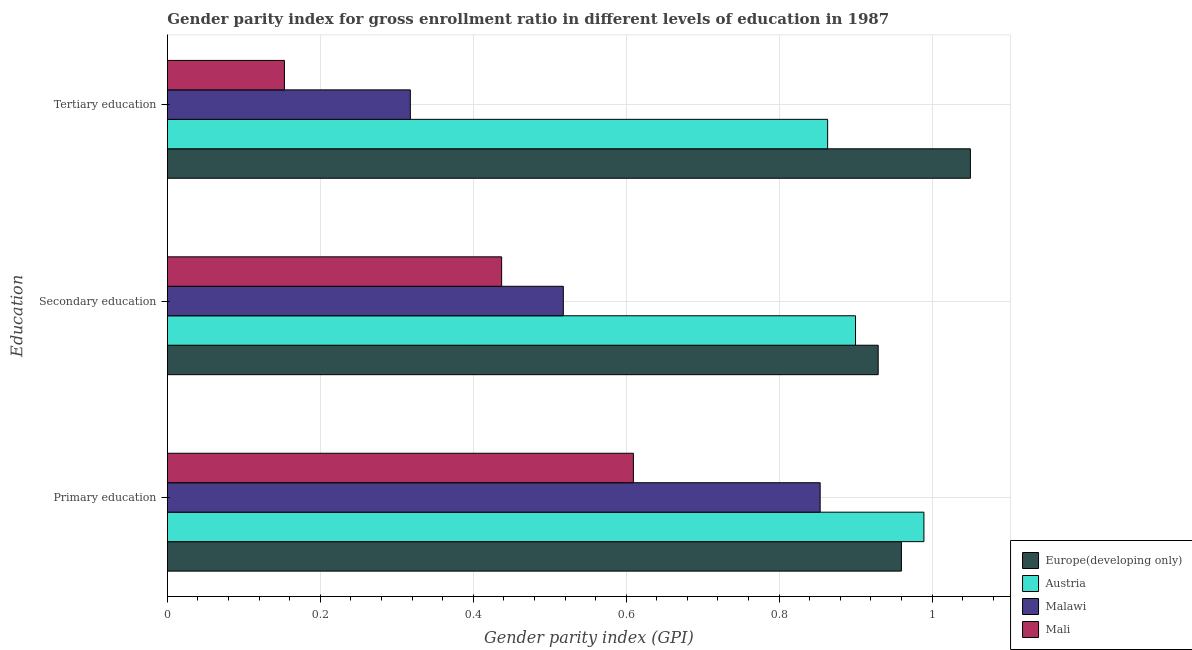How many different coloured bars are there?
Your answer should be compact. 4. How many bars are there on the 1st tick from the top?
Keep it short and to the point. 4. How many bars are there on the 3rd tick from the bottom?
Your response must be concise. 4. What is the label of the 3rd group of bars from the top?
Keep it short and to the point. Primary education. What is the gender parity index in secondary education in Malawi?
Keep it short and to the point. 0.52. Across all countries, what is the maximum gender parity index in secondary education?
Provide a succinct answer. 0.93. Across all countries, what is the minimum gender parity index in secondary education?
Provide a short and direct response. 0.44. In which country was the gender parity index in secondary education maximum?
Offer a terse response. Europe(developing only). In which country was the gender parity index in secondary education minimum?
Offer a very short reply. Mali. What is the total gender parity index in secondary education in the graph?
Offer a very short reply. 2.78. What is the difference between the gender parity index in secondary education in Malawi and that in Austria?
Offer a very short reply. -0.38. What is the difference between the gender parity index in secondary education in Europe(developing only) and the gender parity index in tertiary education in Malawi?
Ensure brevity in your answer.  0.61. What is the average gender parity index in primary education per country?
Offer a very short reply. 0.85. What is the difference between the gender parity index in primary education and gender parity index in secondary education in Malawi?
Provide a succinct answer. 0.34. In how many countries, is the gender parity index in primary education greater than 0.92 ?
Ensure brevity in your answer.  2. What is the ratio of the gender parity index in primary education in Austria to that in Europe(developing only)?
Offer a terse response. 1.03. Is the gender parity index in secondary education in Austria less than that in Europe(developing only)?
Give a very brief answer. Yes. What is the difference between the highest and the second highest gender parity index in secondary education?
Your response must be concise. 0.03. What is the difference between the highest and the lowest gender parity index in tertiary education?
Provide a short and direct response. 0.9. In how many countries, is the gender parity index in tertiary education greater than the average gender parity index in tertiary education taken over all countries?
Ensure brevity in your answer.  2. What does the 4th bar from the top in Primary education represents?
Give a very brief answer. Europe(developing only). What does the 4th bar from the bottom in Tertiary education represents?
Provide a short and direct response. Mali. How many bars are there?
Offer a terse response. 12. How many countries are there in the graph?
Give a very brief answer. 4. Does the graph contain any zero values?
Keep it short and to the point. No. Does the graph contain grids?
Offer a terse response. Yes. Where does the legend appear in the graph?
Give a very brief answer. Bottom right. How many legend labels are there?
Make the answer very short. 4. What is the title of the graph?
Your response must be concise. Gender parity index for gross enrollment ratio in different levels of education in 1987. What is the label or title of the X-axis?
Your response must be concise. Gender parity index (GPI). What is the label or title of the Y-axis?
Keep it short and to the point. Education. What is the Gender parity index (GPI) of Europe(developing only) in Primary education?
Your response must be concise. 0.96. What is the Gender parity index (GPI) of Austria in Primary education?
Give a very brief answer. 0.99. What is the Gender parity index (GPI) of Malawi in Primary education?
Make the answer very short. 0.85. What is the Gender parity index (GPI) in Mali in Primary education?
Your answer should be very brief. 0.61. What is the Gender parity index (GPI) of Europe(developing only) in Secondary education?
Make the answer very short. 0.93. What is the Gender parity index (GPI) in Austria in Secondary education?
Give a very brief answer. 0.9. What is the Gender parity index (GPI) in Malawi in Secondary education?
Offer a very short reply. 0.52. What is the Gender parity index (GPI) of Mali in Secondary education?
Provide a succinct answer. 0.44. What is the Gender parity index (GPI) of Europe(developing only) in Tertiary education?
Make the answer very short. 1.05. What is the Gender parity index (GPI) in Austria in Tertiary education?
Your answer should be compact. 0.86. What is the Gender parity index (GPI) in Malawi in Tertiary education?
Your answer should be very brief. 0.32. What is the Gender parity index (GPI) in Mali in Tertiary education?
Keep it short and to the point. 0.15. Across all Education, what is the maximum Gender parity index (GPI) of Europe(developing only)?
Give a very brief answer. 1.05. Across all Education, what is the maximum Gender parity index (GPI) of Austria?
Provide a short and direct response. 0.99. Across all Education, what is the maximum Gender parity index (GPI) in Malawi?
Your response must be concise. 0.85. Across all Education, what is the maximum Gender parity index (GPI) of Mali?
Give a very brief answer. 0.61. Across all Education, what is the minimum Gender parity index (GPI) in Europe(developing only)?
Provide a short and direct response. 0.93. Across all Education, what is the minimum Gender parity index (GPI) of Austria?
Your answer should be compact. 0.86. Across all Education, what is the minimum Gender parity index (GPI) in Malawi?
Offer a terse response. 0.32. Across all Education, what is the minimum Gender parity index (GPI) in Mali?
Your response must be concise. 0.15. What is the total Gender parity index (GPI) in Europe(developing only) in the graph?
Keep it short and to the point. 2.94. What is the total Gender parity index (GPI) of Austria in the graph?
Provide a succinct answer. 2.75. What is the total Gender parity index (GPI) in Malawi in the graph?
Your answer should be very brief. 1.69. What is the total Gender parity index (GPI) in Mali in the graph?
Offer a terse response. 1.2. What is the difference between the Gender parity index (GPI) of Europe(developing only) in Primary education and that in Secondary education?
Ensure brevity in your answer.  0.03. What is the difference between the Gender parity index (GPI) in Austria in Primary education and that in Secondary education?
Offer a very short reply. 0.09. What is the difference between the Gender parity index (GPI) in Malawi in Primary education and that in Secondary education?
Offer a very short reply. 0.34. What is the difference between the Gender parity index (GPI) in Mali in Primary education and that in Secondary education?
Give a very brief answer. 0.17. What is the difference between the Gender parity index (GPI) of Europe(developing only) in Primary education and that in Tertiary education?
Provide a succinct answer. -0.09. What is the difference between the Gender parity index (GPI) in Austria in Primary education and that in Tertiary education?
Your answer should be very brief. 0.13. What is the difference between the Gender parity index (GPI) in Malawi in Primary education and that in Tertiary education?
Offer a terse response. 0.54. What is the difference between the Gender parity index (GPI) in Mali in Primary education and that in Tertiary education?
Your response must be concise. 0.46. What is the difference between the Gender parity index (GPI) of Europe(developing only) in Secondary education and that in Tertiary education?
Your answer should be compact. -0.12. What is the difference between the Gender parity index (GPI) of Austria in Secondary education and that in Tertiary education?
Keep it short and to the point. 0.04. What is the difference between the Gender parity index (GPI) of Mali in Secondary education and that in Tertiary education?
Give a very brief answer. 0.28. What is the difference between the Gender parity index (GPI) in Europe(developing only) in Primary education and the Gender parity index (GPI) in Austria in Secondary education?
Your answer should be compact. 0.06. What is the difference between the Gender parity index (GPI) in Europe(developing only) in Primary education and the Gender parity index (GPI) in Malawi in Secondary education?
Keep it short and to the point. 0.44. What is the difference between the Gender parity index (GPI) of Europe(developing only) in Primary education and the Gender parity index (GPI) of Mali in Secondary education?
Make the answer very short. 0.52. What is the difference between the Gender parity index (GPI) of Austria in Primary education and the Gender parity index (GPI) of Malawi in Secondary education?
Provide a short and direct response. 0.47. What is the difference between the Gender parity index (GPI) of Austria in Primary education and the Gender parity index (GPI) of Mali in Secondary education?
Make the answer very short. 0.55. What is the difference between the Gender parity index (GPI) in Malawi in Primary education and the Gender parity index (GPI) in Mali in Secondary education?
Your answer should be very brief. 0.42. What is the difference between the Gender parity index (GPI) of Europe(developing only) in Primary education and the Gender parity index (GPI) of Austria in Tertiary education?
Offer a terse response. 0.1. What is the difference between the Gender parity index (GPI) of Europe(developing only) in Primary education and the Gender parity index (GPI) of Malawi in Tertiary education?
Keep it short and to the point. 0.64. What is the difference between the Gender parity index (GPI) in Europe(developing only) in Primary education and the Gender parity index (GPI) in Mali in Tertiary education?
Your answer should be very brief. 0.81. What is the difference between the Gender parity index (GPI) of Austria in Primary education and the Gender parity index (GPI) of Malawi in Tertiary education?
Keep it short and to the point. 0.67. What is the difference between the Gender parity index (GPI) of Austria in Primary education and the Gender parity index (GPI) of Mali in Tertiary education?
Keep it short and to the point. 0.84. What is the difference between the Gender parity index (GPI) of Malawi in Primary education and the Gender parity index (GPI) of Mali in Tertiary education?
Offer a terse response. 0.7. What is the difference between the Gender parity index (GPI) in Europe(developing only) in Secondary education and the Gender parity index (GPI) in Austria in Tertiary education?
Your answer should be compact. 0.07. What is the difference between the Gender parity index (GPI) in Europe(developing only) in Secondary education and the Gender parity index (GPI) in Malawi in Tertiary education?
Give a very brief answer. 0.61. What is the difference between the Gender parity index (GPI) in Europe(developing only) in Secondary education and the Gender parity index (GPI) in Mali in Tertiary education?
Keep it short and to the point. 0.78. What is the difference between the Gender parity index (GPI) of Austria in Secondary education and the Gender parity index (GPI) of Malawi in Tertiary education?
Offer a very short reply. 0.58. What is the difference between the Gender parity index (GPI) in Austria in Secondary education and the Gender parity index (GPI) in Mali in Tertiary education?
Ensure brevity in your answer.  0.75. What is the difference between the Gender parity index (GPI) of Malawi in Secondary education and the Gender parity index (GPI) of Mali in Tertiary education?
Offer a very short reply. 0.36. What is the average Gender parity index (GPI) of Europe(developing only) per Education?
Your answer should be compact. 0.98. What is the average Gender parity index (GPI) in Austria per Education?
Your answer should be compact. 0.92. What is the average Gender parity index (GPI) of Malawi per Education?
Offer a terse response. 0.56. What is the average Gender parity index (GPI) of Mali per Education?
Your answer should be very brief. 0.4. What is the difference between the Gender parity index (GPI) of Europe(developing only) and Gender parity index (GPI) of Austria in Primary education?
Give a very brief answer. -0.03. What is the difference between the Gender parity index (GPI) of Europe(developing only) and Gender parity index (GPI) of Malawi in Primary education?
Ensure brevity in your answer.  0.11. What is the difference between the Gender parity index (GPI) in Europe(developing only) and Gender parity index (GPI) in Mali in Primary education?
Give a very brief answer. 0.35. What is the difference between the Gender parity index (GPI) in Austria and Gender parity index (GPI) in Malawi in Primary education?
Ensure brevity in your answer.  0.14. What is the difference between the Gender parity index (GPI) of Austria and Gender parity index (GPI) of Mali in Primary education?
Offer a very short reply. 0.38. What is the difference between the Gender parity index (GPI) in Malawi and Gender parity index (GPI) in Mali in Primary education?
Make the answer very short. 0.24. What is the difference between the Gender parity index (GPI) in Europe(developing only) and Gender parity index (GPI) in Austria in Secondary education?
Keep it short and to the point. 0.03. What is the difference between the Gender parity index (GPI) in Europe(developing only) and Gender parity index (GPI) in Malawi in Secondary education?
Your answer should be very brief. 0.41. What is the difference between the Gender parity index (GPI) in Europe(developing only) and Gender parity index (GPI) in Mali in Secondary education?
Make the answer very short. 0.49. What is the difference between the Gender parity index (GPI) of Austria and Gender parity index (GPI) of Malawi in Secondary education?
Your response must be concise. 0.38. What is the difference between the Gender parity index (GPI) in Austria and Gender parity index (GPI) in Mali in Secondary education?
Give a very brief answer. 0.46. What is the difference between the Gender parity index (GPI) in Malawi and Gender parity index (GPI) in Mali in Secondary education?
Your response must be concise. 0.08. What is the difference between the Gender parity index (GPI) of Europe(developing only) and Gender parity index (GPI) of Austria in Tertiary education?
Make the answer very short. 0.19. What is the difference between the Gender parity index (GPI) in Europe(developing only) and Gender parity index (GPI) in Malawi in Tertiary education?
Your response must be concise. 0.73. What is the difference between the Gender parity index (GPI) of Europe(developing only) and Gender parity index (GPI) of Mali in Tertiary education?
Provide a succinct answer. 0.9. What is the difference between the Gender parity index (GPI) of Austria and Gender parity index (GPI) of Malawi in Tertiary education?
Provide a short and direct response. 0.55. What is the difference between the Gender parity index (GPI) of Austria and Gender parity index (GPI) of Mali in Tertiary education?
Your answer should be compact. 0.71. What is the difference between the Gender parity index (GPI) of Malawi and Gender parity index (GPI) of Mali in Tertiary education?
Give a very brief answer. 0.16. What is the ratio of the Gender parity index (GPI) in Europe(developing only) in Primary education to that in Secondary education?
Offer a terse response. 1.03. What is the ratio of the Gender parity index (GPI) of Austria in Primary education to that in Secondary education?
Make the answer very short. 1.1. What is the ratio of the Gender parity index (GPI) of Malawi in Primary education to that in Secondary education?
Make the answer very short. 1.65. What is the ratio of the Gender parity index (GPI) in Mali in Primary education to that in Secondary education?
Offer a terse response. 1.39. What is the ratio of the Gender parity index (GPI) in Europe(developing only) in Primary education to that in Tertiary education?
Keep it short and to the point. 0.91. What is the ratio of the Gender parity index (GPI) of Austria in Primary education to that in Tertiary education?
Your response must be concise. 1.15. What is the ratio of the Gender parity index (GPI) of Malawi in Primary education to that in Tertiary education?
Make the answer very short. 2.69. What is the ratio of the Gender parity index (GPI) of Mali in Primary education to that in Tertiary education?
Offer a very short reply. 3.98. What is the ratio of the Gender parity index (GPI) of Europe(developing only) in Secondary education to that in Tertiary education?
Offer a terse response. 0.89. What is the ratio of the Gender parity index (GPI) in Austria in Secondary education to that in Tertiary education?
Offer a terse response. 1.04. What is the ratio of the Gender parity index (GPI) in Malawi in Secondary education to that in Tertiary education?
Your answer should be very brief. 1.63. What is the ratio of the Gender parity index (GPI) in Mali in Secondary education to that in Tertiary education?
Your answer should be compact. 2.86. What is the difference between the highest and the second highest Gender parity index (GPI) in Europe(developing only)?
Ensure brevity in your answer.  0.09. What is the difference between the highest and the second highest Gender parity index (GPI) in Austria?
Keep it short and to the point. 0.09. What is the difference between the highest and the second highest Gender parity index (GPI) in Malawi?
Your answer should be very brief. 0.34. What is the difference between the highest and the second highest Gender parity index (GPI) in Mali?
Provide a short and direct response. 0.17. What is the difference between the highest and the lowest Gender parity index (GPI) of Europe(developing only)?
Provide a succinct answer. 0.12. What is the difference between the highest and the lowest Gender parity index (GPI) of Austria?
Offer a terse response. 0.13. What is the difference between the highest and the lowest Gender parity index (GPI) in Malawi?
Your answer should be compact. 0.54. What is the difference between the highest and the lowest Gender parity index (GPI) in Mali?
Ensure brevity in your answer.  0.46. 